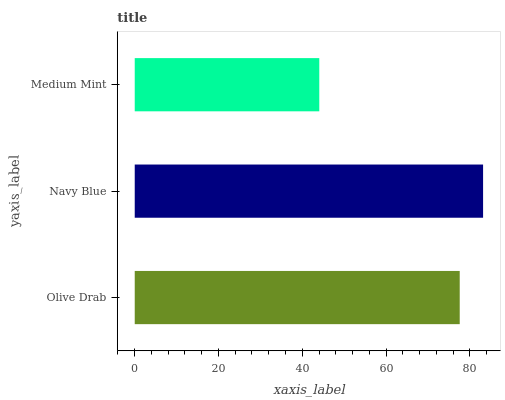Is Medium Mint the minimum?
Answer yes or no. Yes. Is Navy Blue the maximum?
Answer yes or no. Yes. Is Navy Blue the minimum?
Answer yes or no. No. Is Medium Mint the maximum?
Answer yes or no. No. Is Navy Blue greater than Medium Mint?
Answer yes or no. Yes. Is Medium Mint less than Navy Blue?
Answer yes or no. Yes. Is Medium Mint greater than Navy Blue?
Answer yes or no. No. Is Navy Blue less than Medium Mint?
Answer yes or no. No. Is Olive Drab the high median?
Answer yes or no. Yes. Is Olive Drab the low median?
Answer yes or no. Yes. Is Navy Blue the high median?
Answer yes or no. No. Is Medium Mint the low median?
Answer yes or no. No. 